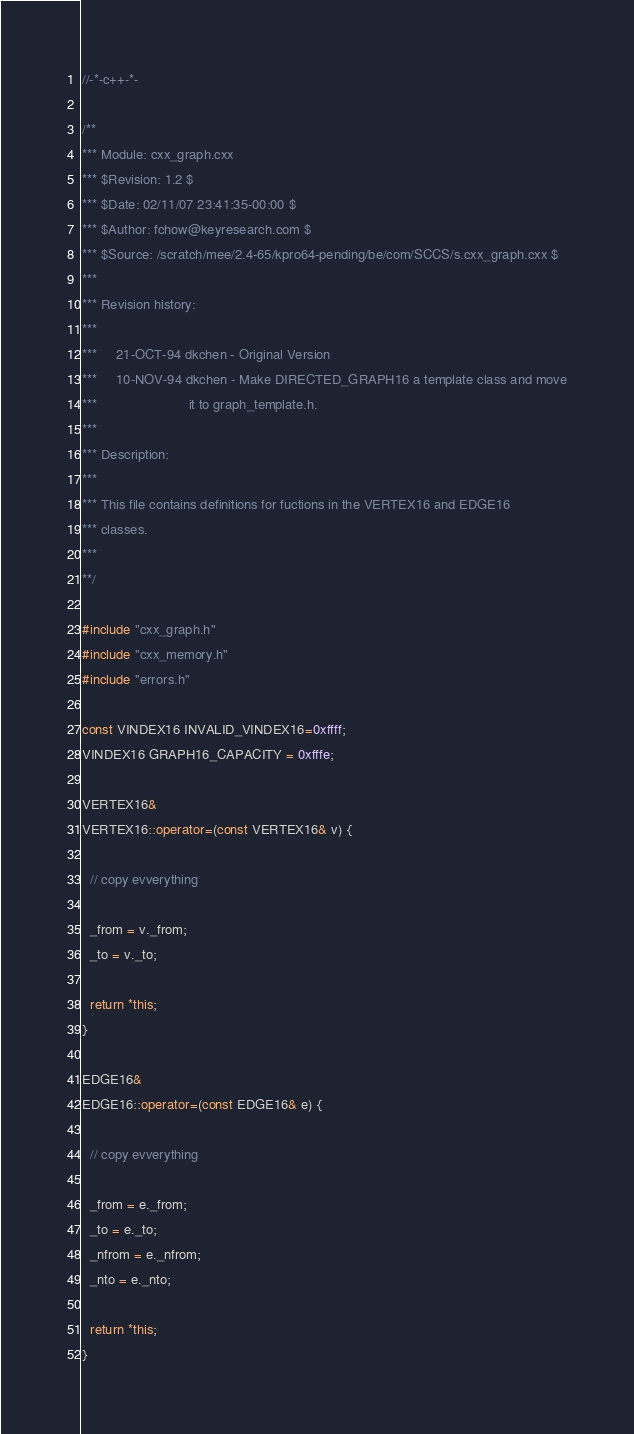Convert code to text. <code><loc_0><loc_0><loc_500><loc_500><_C++_>//-*-c++-*-

/**
*** Module: cxx_graph.cxx
*** $Revision: 1.2 $
*** $Date: 02/11/07 23:41:35-00:00 $
*** $Author: fchow@keyresearch.com $
*** $Source: /scratch/mee/2.4-65/kpro64-pending/be/com/SCCS/s.cxx_graph.cxx $
*** 
*** Revision history:
*** 
***     21-OCT-94 dkchen - Original Version
***     10-NOV-94 dkchen - Make DIRECTED_GRAPH16 a template class and move
***                        it to graph_template.h.
*** 
*** Description:
*** 
*** This file contains definitions for fuctions in the VERTEX16 and EDGE16
*** classes.
*** 
**/

#include "cxx_graph.h"
#include "cxx_memory.h"
#include "errors.h"

const VINDEX16 INVALID_VINDEX16=0xffff;
VINDEX16 GRAPH16_CAPACITY = 0xfffe;

VERTEX16&
VERTEX16::operator=(const VERTEX16& v) {

  // copy evverything

  _from = v._from;
  _to = v._to;

  return *this;
}

EDGE16&
EDGE16::operator=(const EDGE16& e) {

  // copy evverything

  _from = e._from;
  _to = e._to;
  _nfrom = e._nfrom;
  _nto = e._nto;

  return *this;
}

</code> 